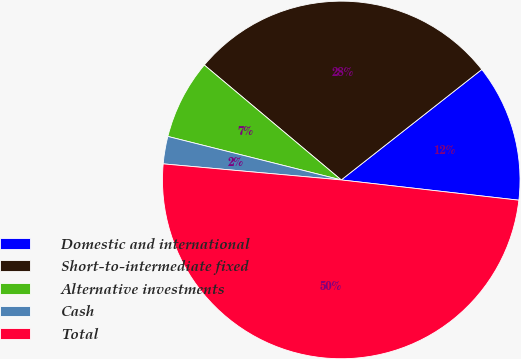<chart> <loc_0><loc_0><loc_500><loc_500><pie_chart><fcel>Domestic and international<fcel>Short-to-intermediate fixed<fcel>Alternative investments<fcel>Cash<fcel>Total<nl><fcel>12.41%<fcel>28.29%<fcel>7.2%<fcel>2.48%<fcel>49.63%<nl></chart> 